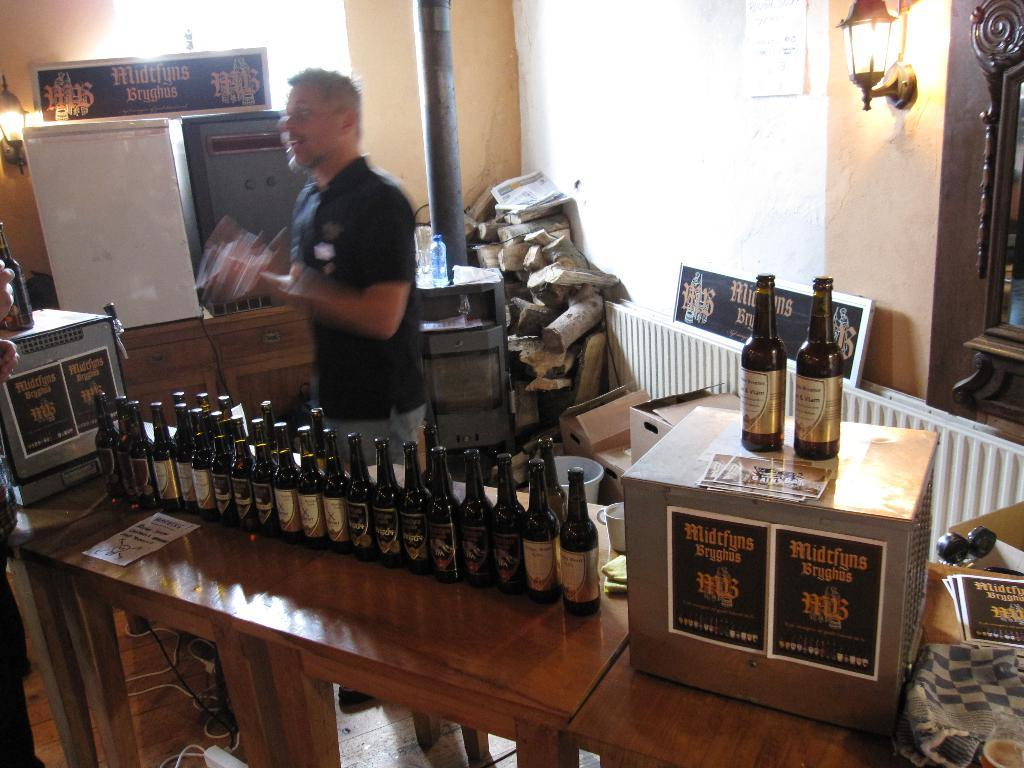Who is present in the image? There is a man in the image. What is in front of the man? There is a table in front of the man. What items can be seen on the table? There are bottles and boxes on the table. What can be seen in the background of the image? There is a wall, a light, and additional objects visible in the background of the image. How many friends are sitting with the man in the image? There are no friends present in the image; only the man is visible. What type of sheep can be seen grazing in the background of the image? There are no sheep present in the image; the background features a wall, a light, and additional objects. 